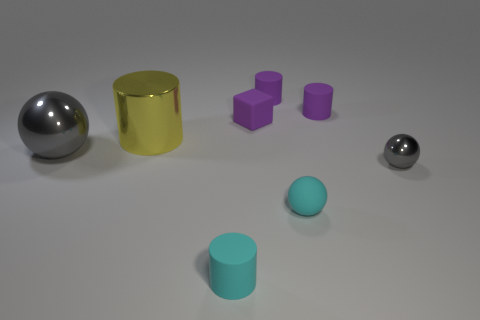Is there any other thing that has the same material as the small purple cube?
Offer a terse response. Yes. The cyan rubber object that is the same shape as the big gray object is what size?
Give a very brief answer. Small. What is the large object on the right side of the big gray metallic object made of?
Offer a terse response. Metal. Are there fewer metallic cylinders on the left side of the big gray metallic object than large yellow cylinders?
Make the answer very short. Yes. What is the shape of the thing behind the matte object that is to the right of the tiny cyan matte ball?
Provide a short and direct response. Cylinder. What color is the metallic cylinder?
Offer a terse response. Yellow. How many other objects are the same size as the rubber cube?
Make the answer very short. 5. What is the material of the thing that is both left of the cyan matte cylinder and in front of the yellow object?
Your answer should be very brief. Metal. There is a gray thing to the right of the cube; is it the same size as the cyan ball?
Provide a short and direct response. Yes. Do the tiny block and the tiny metallic ball have the same color?
Offer a very short reply. No. 